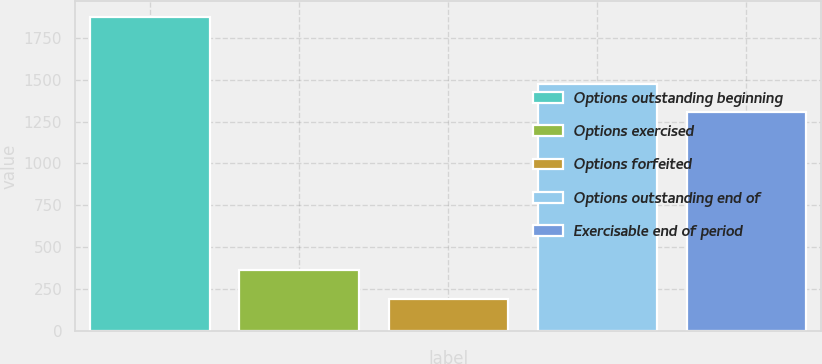<chart> <loc_0><loc_0><loc_500><loc_500><bar_chart><fcel>Options outstanding beginning<fcel>Options exercised<fcel>Options forfeited<fcel>Options outstanding end of<fcel>Exercisable end of period<nl><fcel>1878<fcel>360.6<fcel>192<fcel>1477.6<fcel>1309<nl></chart> 